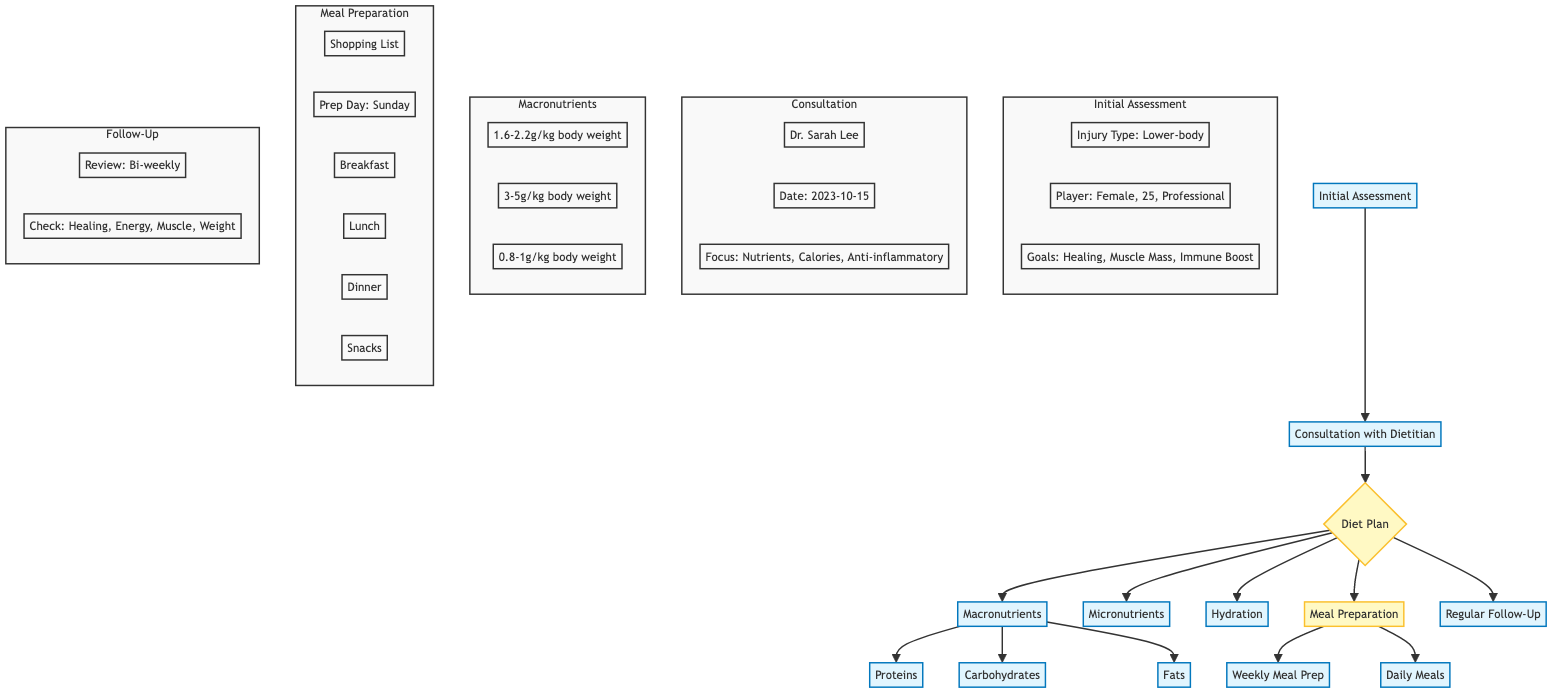What is the injury type identified in the assessment? The flow chart specifies the injury type under the "Initial Assessment" section, which lists "Lower-body injury" as the injury type.
Answer: Lower-body injury Who is the dietitian consulted for the nutrition plan? The chart includes a "Consultation with Dietitian" section that explicitly states the name of the consulted dietitian as "Dr. Sarah Lee."
Answer: Dr. Sarah Lee What is the hydration target stated in the diet plan? The Diet Plan includes a section on Hydration where it clearly states the target for daily water intake as "3 liters of water daily."
Answer: 3 liters of water daily How often is the regular follow-up scheduled? Within the "Regular Follow-Up" node, it indicates the frequency of the follow-up reviews as "Bi-weekly."
Answer: Bi-weekly What are the targets for protein intake according to the diet plan? The Diet Plan details macronutrients, and specifically for proteins, it lists the target as "1.6-2.2 grams per kg of body weight."
Answer: 1.6-2.2 grams per kg of body weight What main focuses were discussed during the consultation with the dietitian? The "Consultation with Dietitian" segment contains key focuses listed, including "Macro and micronutrient needs," "Caloric intake adjustment," and "Anti-inflammatory foods." Combining these focuses indicates the dietitian's focus areas.
Answer: Macro and micronutrient needs, caloric intake adjustment, anti-inflammatory foods List two sources of carbohydrates mentioned in the diet plan. The "Diet Plan" section specifies various sources of carbohydrates under the Macronutrients part, where it specifically lists "Brown rice" and "Sweet potatoes" as examples.
Answer: Brown rice, Sweet potatoes What is the prep day for the weekly meal preparation? In the "Meal Preparation" section, it mentions clearly that the "Prep Day" is set for "Sunday."
Answer: Sunday How many main meal groups are predefined in the daily meals? The "Daily Meals" part of the "Meal Preparation" section outlines four main meal groups: Breakfast, Lunch, Dinner, and Snacks. The count of these groups leads to the conclusion.
Answer: 4 